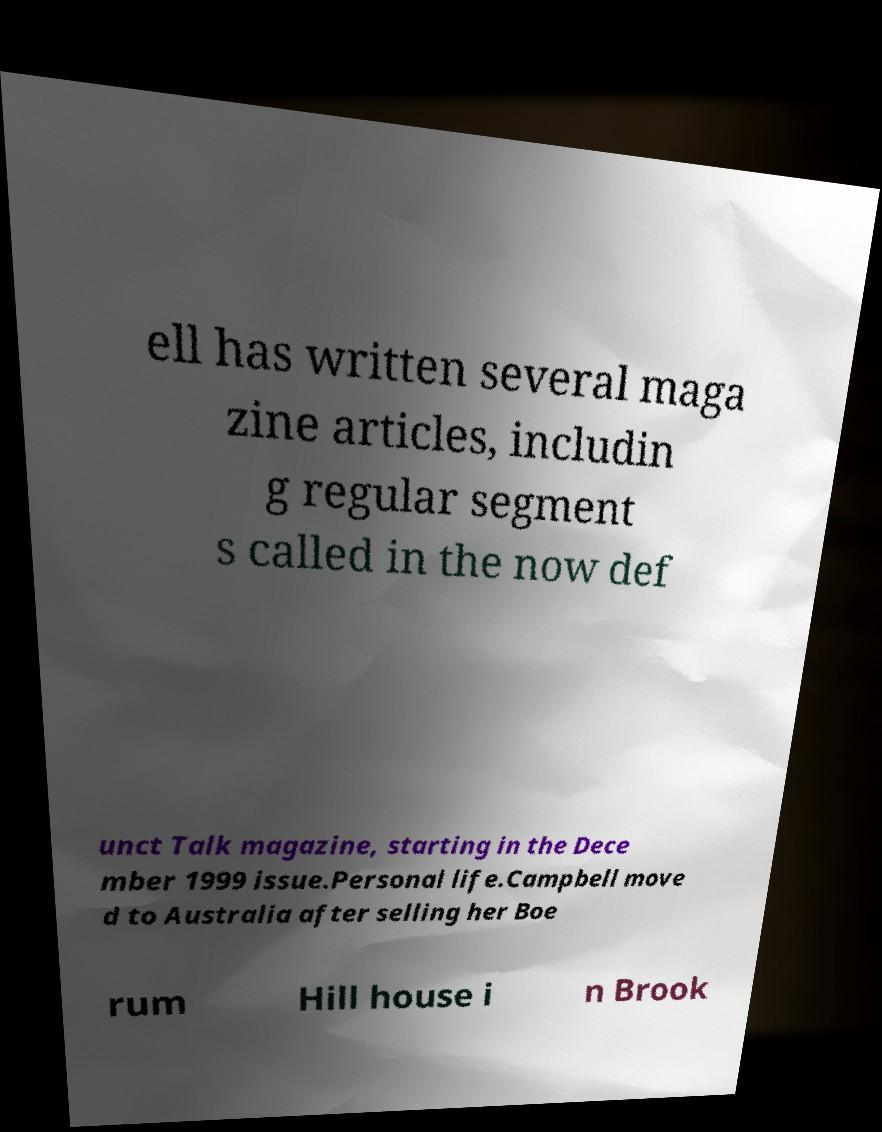There's text embedded in this image that I need extracted. Can you transcribe it verbatim? ell has written several maga zine articles, includin g regular segment s called in the now def unct Talk magazine, starting in the Dece mber 1999 issue.Personal life.Campbell move d to Australia after selling her Boe rum Hill house i n Brook 